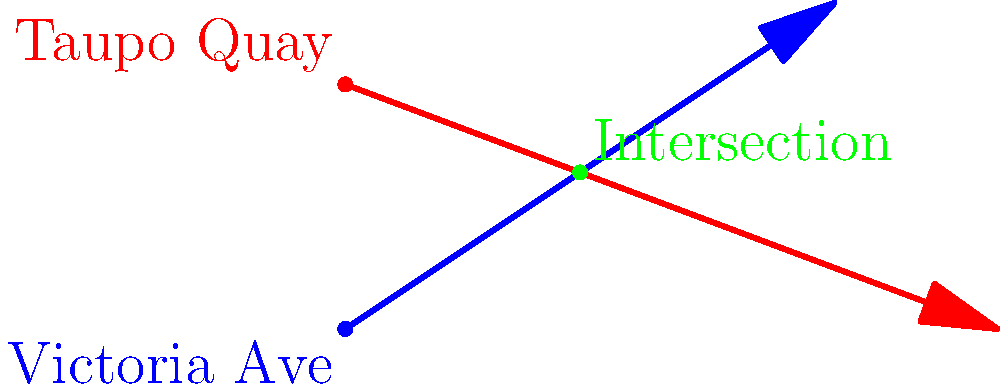In downtown Whanganui, Victoria Avenue can be represented by the line $y = \frac{2}{3}x$, and Taupo Quay can be represented by the line $y = -\frac{3}{8}x + 3$. At which point do these two streets intersect? To find the intersection point of these two streets, we need to solve the system of equations:

1) Victoria Avenue: $y = \frac{2}{3}x$
2) Taupo Quay: $y = -\frac{3}{8}x + 3$

Let's solve this step-by-step:

1) Set the equations equal to each other:
   $\frac{2}{3}x = -\frac{3}{8}x + 3$

2) Multiply both sides by 24 to eliminate fractions:
   $16x = -9x + 72$

3) Add 9x to both sides:
   $25x = 72$

4) Divide both sides by 25:
   $x = \frac{72}{25} = 2.88$

5) Substitute this x-value into either equation. Let's use Victoria Avenue's equation:
   $y = \frac{2}{3}(2.88) = 1.92$

Therefore, the intersection point is $(2.88, 1.92)$.
Answer: $(2.88, 1.92)$ 